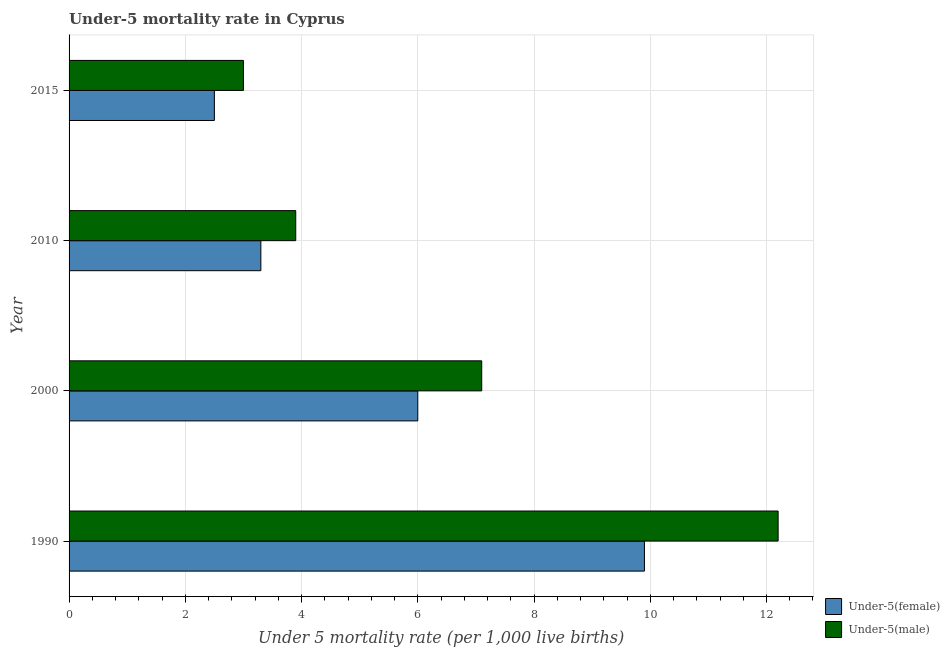How many groups of bars are there?
Provide a short and direct response. 4. How many bars are there on the 4th tick from the top?
Keep it short and to the point. 2. How many bars are there on the 1st tick from the bottom?
Make the answer very short. 2. What is the label of the 1st group of bars from the top?
Provide a short and direct response. 2015. In which year was the under-5 male mortality rate minimum?
Make the answer very short. 2015. What is the total under-5 male mortality rate in the graph?
Offer a terse response. 26.2. What is the difference between the under-5 female mortality rate in 1990 and the under-5 male mortality rate in 2010?
Offer a terse response. 6. What is the average under-5 female mortality rate per year?
Provide a short and direct response. 5.42. In how many years, is the under-5 male mortality rate greater than 3.6 ?
Ensure brevity in your answer.  3. What is the ratio of the under-5 male mortality rate in 1990 to that in 2000?
Offer a very short reply. 1.72. Is the under-5 female mortality rate in 1990 less than that in 2010?
Ensure brevity in your answer.  No. Is the difference between the under-5 female mortality rate in 1990 and 2015 greater than the difference between the under-5 male mortality rate in 1990 and 2015?
Provide a short and direct response. No. What is the difference between the highest and the second highest under-5 male mortality rate?
Give a very brief answer. 5.1. What is the difference between the highest and the lowest under-5 male mortality rate?
Offer a very short reply. 9.2. What does the 2nd bar from the top in 1990 represents?
Your response must be concise. Under-5(female). What does the 2nd bar from the bottom in 1990 represents?
Your answer should be very brief. Under-5(male). Are the values on the major ticks of X-axis written in scientific E-notation?
Give a very brief answer. No. Does the graph contain any zero values?
Make the answer very short. No. Does the graph contain grids?
Provide a short and direct response. Yes. What is the title of the graph?
Ensure brevity in your answer.  Under-5 mortality rate in Cyprus. What is the label or title of the X-axis?
Your answer should be compact. Under 5 mortality rate (per 1,0 live births). What is the label or title of the Y-axis?
Your response must be concise. Year. What is the Under 5 mortality rate (per 1,000 live births) of Under-5(female) in 1990?
Your answer should be very brief. 9.9. What is the Under 5 mortality rate (per 1,000 live births) in Under-5(male) in 1990?
Offer a terse response. 12.2. What is the Under 5 mortality rate (per 1,000 live births) of Under-5(female) in 2010?
Offer a terse response. 3.3. What is the Under 5 mortality rate (per 1,000 live births) of Under-5(female) in 2015?
Ensure brevity in your answer.  2.5. Across all years, what is the maximum Under 5 mortality rate (per 1,000 live births) of Under-5(male)?
Make the answer very short. 12.2. What is the total Under 5 mortality rate (per 1,000 live births) of Under-5(female) in the graph?
Make the answer very short. 21.7. What is the total Under 5 mortality rate (per 1,000 live births) in Under-5(male) in the graph?
Offer a very short reply. 26.2. What is the difference between the Under 5 mortality rate (per 1,000 live births) in Under-5(male) in 1990 and that in 2000?
Give a very brief answer. 5.1. What is the difference between the Under 5 mortality rate (per 1,000 live births) of Under-5(female) in 1990 and that in 2010?
Provide a succinct answer. 6.6. What is the difference between the Under 5 mortality rate (per 1,000 live births) of Under-5(female) in 1990 and that in 2015?
Provide a short and direct response. 7.4. What is the difference between the Under 5 mortality rate (per 1,000 live births) in Under-5(male) in 2000 and that in 2010?
Offer a very short reply. 3.2. What is the difference between the Under 5 mortality rate (per 1,000 live births) of Under-5(female) in 2000 and that in 2015?
Make the answer very short. 3.5. What is the difference between the Under 5 mortality rate (per 1,000 live births) in Under-5(male) in 2000 and that in 2015?
Make the answer very short. 4.1. What is the difference between the Under 5 mortality rate (per 1,000 live births) of Under-5(male) in 2010 and that in 2015?
Give a very brief answer. 0.9. What is the difference between the Under 5 mortality rate (per 1,000 live births) in Under-5(female) in 1990 and the Under 5 mortality rate (per 1,000 live births) in Under-5(male) in 2010?
Give a very brief answer. 6. What is the difference between the Under 5 mortality rate (per 1,000 live births) of Under-5(female) in 2000 and the Under 5 mortality rate (per 1,000 live births) of Under-5(male) in 2015?
Provide a short and direct response. 3. What is the average Under 5 mortality rate (per 1,000 live births) of Under-5(female) per year?
Your answer should be compact. 5.42. What is the average Under 5 mortality rate (per 1,000 live births) of Under-5(male) per year?
Ensure brevity in your answer.  6.55. In the year 1990, what is the difference between the Under 5 mortality rate (per 1,000 live births) of Under-5(female) and Under 5 mortality rate (per 1,000 live births) of Under-5(male)?
Make the answer very short. -2.3. In the year 2000, what is the difference between the Under 5 mortality rate (per 1,000 live births) of Under-5(female) and Under 5 mortality rate (per 1,000 live births) of Under-5(male)?
Your answer should be very brief. -1.1. In the year 2010, what is the difference between the Under 5 mortality rate (per 1,000 live births) of Under-5(female) and Under 5 mortality rate (per 1,000 live births) of Under-5(male)?
Provide a succinct answer. -0.6. What is the ratio of the Under 5 mortality rate (per 1,000 live births) in Under-5(female) in 1990 to that in 2000?
Ensure brevity in your answer.  1.65. What is the ratio of the Under 5 mortality rate (per 1,000 live births) in Under-5(male) in 1990 to that in 2000?
Keep it short and to the point. 1.72. What is the ratio of the Under 5 mortality rate (per 1,000 live births) of Under-5(female) in 1990 to that in 2010?
Ensure brevity in your answer.  3. What is the ratio of the Under 5 mortality rate (per 1,000 live births) of Under-5(male) in 1990 to that in 2010?
Provide a short and direct response. 3.13. What is the ratio of the Under 5 mortality rate (per 1,000 live births) in Under-5(female) in 1990 to that in 2015?
Offer a terse response. 3.96. What is the ratio of the Under 5 mortality rate (per 1,000 live births) of Under-5(male) in 1990 to that in 2015?
Make the answer very short. 4.07. What is the ratio of the Under 5 mortality rate (per 1,000 live births) of Under-5(female) in 2000 to that in 2010?
Give a very brief answer. 1.82. What is the ratio of the Under 5 mortality rate (per 1,000 live births) of Under-5(male) in 2000 to that in 2010?
Offer a terse response. 1.82. What is the ratio of the Under 5 mortality rate (per 1,000 live births) in Under-5(male) in 2000 to that in 2015?
Make the answer very short. 2.37. What is the ratio of the Under 5 mortality rate (per 1,000 live births) in Under-5(female) in 2010 to that in 2015?
Keep it short and to the point. 1.32. What is the ratio of the Under 5 mortality rate (per 1,000 live births) of Under-5(male) in 2010 to that in 2015?
Your answer should be very brief. 1.3. What is the difference between the highest and the second highest Under 5 mortality rate (per 1,000 live births) in Under-5(female)?
Provide a short and direct response. 3.9. What is the difference between the highest and the lowest Under 5 mortality rate (per 1,000 live births) of Under-5(female)?
Your answer should be very brief. 7.4. What is the difference between the highest and the lowest Under 5 mortality rate (per 1,000 live births) of Under-5(male)?
Provide a short and direct response. 9.2. 